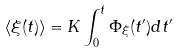Convert formula to latex. <formula><loc_0><loc_0><loc_500><loc_500>\langle \xi ( t ) \rangle = K \int _ { 0 } ^ { t } \Phi _ { \xi } ( t ^ { \prime } ) d t ^ { \prime }</formula> 